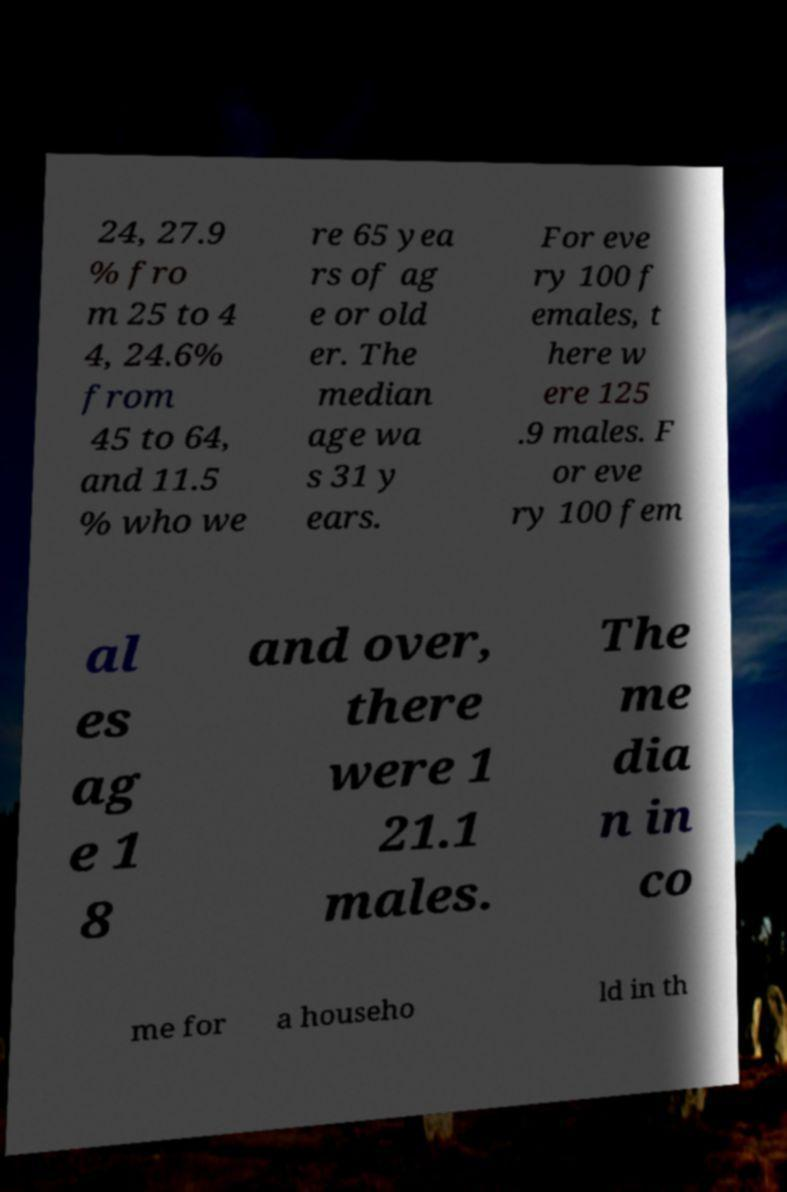What messages or text are displayed in this image? I need them in a readable, typed format. 24, 27.9 % fro m 25 to 4 4, 24.6% from 45 to 64, and 11.5 % who we re 65 yea rs of ag e or old er. The median age wa s 31 y ears. For eve ry 100 f emales, t here w ere 125 .9 males. F or eve ry 100 fem al es ag e 1 8 and over, there were 1 21.1 males. The me dia n in co me for a househo ld in th 